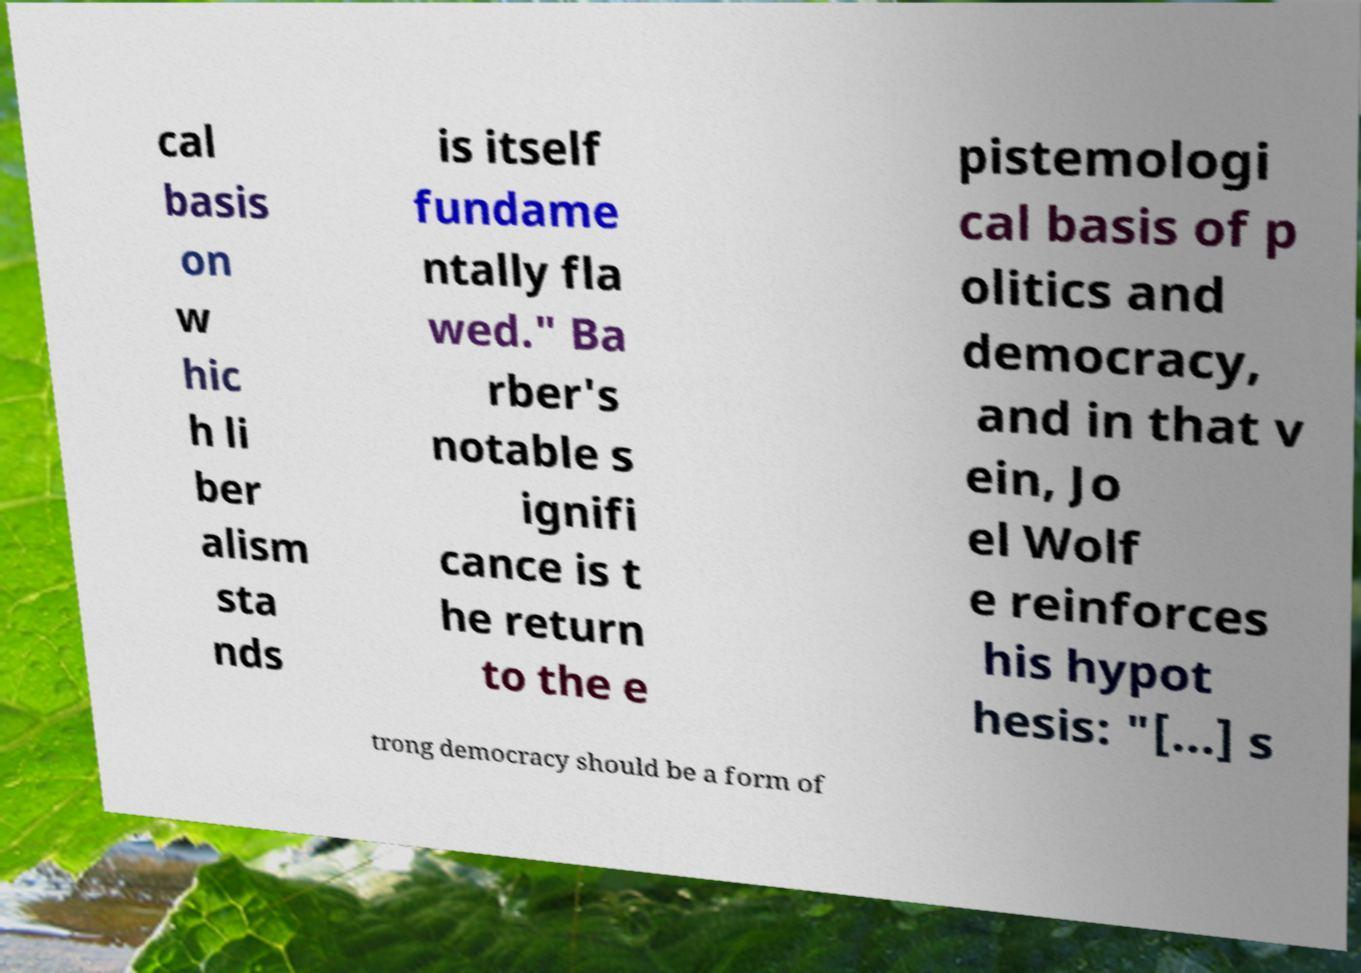What messages or text are displayed in this image? I need them in a readable, typed format. cal basis on w hic h li ber alism sta nds is itself fundame ntally fla wed." Ba rber's notable s ignifi cance is t he return to the e pistemologi cal basis of p olitics and democracy, and in that v ein, Jo el Wolf e reinforces his hypot hesis: "[...] s trong democracy should be a form of 